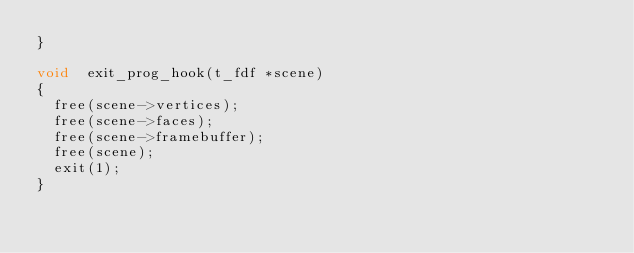<code> <loc_0><loc_0><loc_500><loc_500><_C_>}

void	exit_prog_hook(t_fdf *scene)
{
	free(scene->vertices);
	free(scene->faces);
	free(scene->framebuffer);
	free(scene);
	exit(1);
}
</code> 